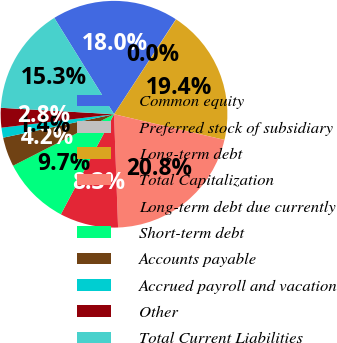<chart> <loc_0><loc_0><loc_500><loc_500><pie_chart><fcel>Common equity<fcel>Preferred stock of subsidiary<fcel>Long-term debt<fcel>Total Capitalization<fcel>Long-term debt due currently<fcel>Short-term debt<fcel>Accounts payable<fcel>Accrued payroll and vacation<fcel>Other<fcel>Total Current Liabilities<nl><fcel>18.03%<fcel>0.03%<fcel>19.41%<fcel>20.8%<fcel>8.34%<fcel>9.72%<fcel>4.19%<fcel>1.42%<fcel>2.8%<fcel>15.26%<nl></chart> 